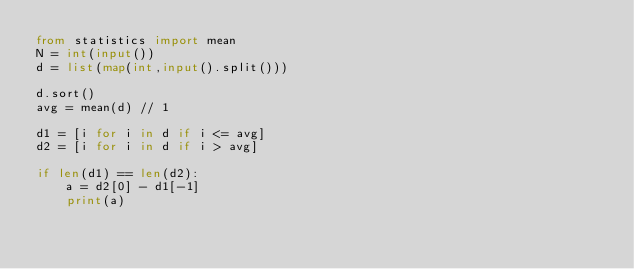<code> <loc_0><loc_0><loc_500><loc_500><_Python_>from statistics import mean
N = int(input())
d = list(map(int,input().split()))

d.sort()
avg = mean(d) // 1

d1 = [i for i in d if i <= avg]
d2 = [i for i in d if i > avg]

if len(d1) == len(d2):
    a = d2[0] - d1[-1]
    print(a)
</code> 